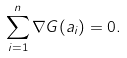Convert formula to latex. <formula><loc_0><loc_0><loc_500><loc_500>\sum _ { i = 1 } ^ { n } \nabla G ( a _ { i } ) = 0 .</formula> 